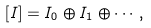Convert formula to latex. <formula><loc_0><loc_0><loc_500><loc_500>[ I ] = I _ { 0 } \oplus I _ { 1 } \oplus \cdots ,</formula> 